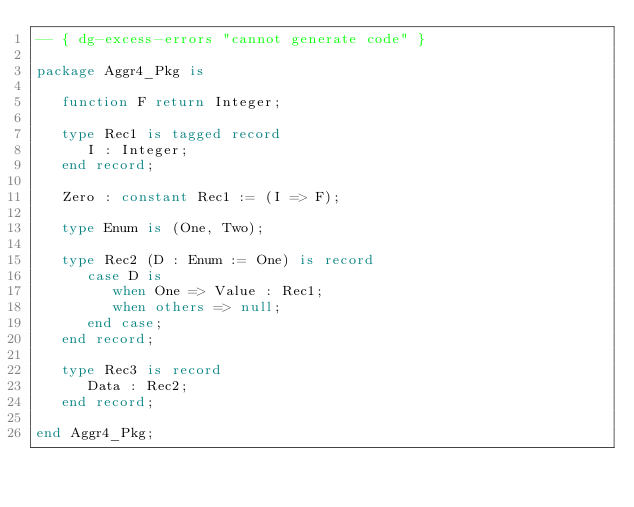<code> <loc_0><loc_0><loc_500><loc_500><_Ada_>-- { dg-excess-errors "cannot generate code" }

package Aggr4_Pkg is

   function F return Integer;

   type Rec1 is tagged record
      I : Integer;
   end record;

   Zero : constant Rec1 := (I => F);

   type Enum is (One, Two);

   type Rec2 (D : Enum := One) is record
      case D is
         when One => Value : Rec1;
         when others => null;
      end case;
   end record;

   type Rec3 is record
      Data : Rec2;
   end record;

end Aggr4_Pkg;
</code> 